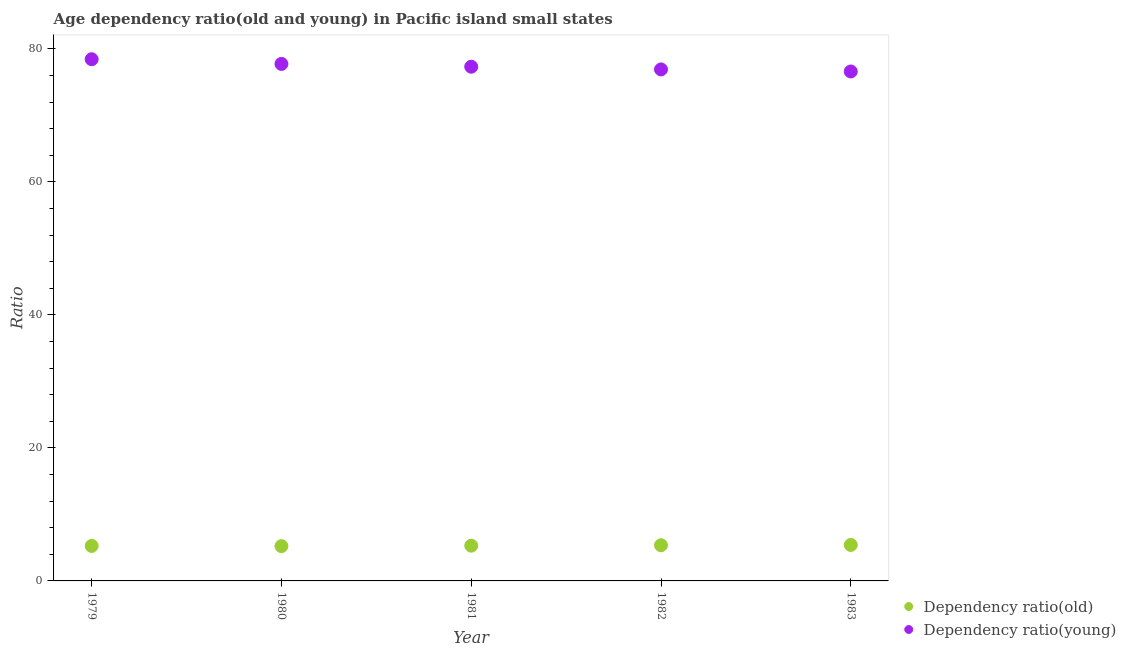How many different coloured dotlines are there?
Give a very brief answer. 2. Is the number of dotlines equal to the number of legend labels?
Keep it short and to the point. Yes. What is the age dependency ratio(old) in 1979?
Provide a succinct answer. 5.26. Across all years, what is the maximum age dependency ratio(young)?
Make the answer very short. 78.45. Across all years, what is the minimum age dependency ratio(old)?
Your answer should be very brief. 5.23. In which year was the age dependency ratio(young) maximum?
Give a very brief answer. 1979. In which year was the age dependency ratio(young) minimum?
Offer a very short reply. 1983. What is the total age dependency ratio(young) in the graph?
Offer a terse response. 387.02. What is the difference between the age dependency ratio(young) in 1980 and that in 1981?
Your response must be concise. 0.42. What is the difference between the age dependency ratio(young) in 1981 and the age dependency ratio(old) in 1979?
Make the answer very short. 72.06. What is the average age dependency ratio(old) per year?
Give a very brief answer. 5.31. In the year 1981, what is the difference between the age dependency ratio(old) and age dependency ratio(young)?
Make the answer very short. -72.02. In how many years, is the age dependency ratio(old) greater than 52?
Give a very brief answer. 0. What is the ratio of the age dependency ratio(old) in 1982 to that in 1983?
Offer a very short reply. 0.99. What is the difference between the highest and the second highest age dependency ratio(young)?
Your answer should be very brief. 0.71. What is the difference between the highest and the lowest age dependency ratio(young)?
Offer a very short reply. 1.84. Does the age dependency ratio(young) monotonically increase over the years?
Offer a very short reply. No. Is the age dependency ratio(young) strictly greater than the age dependency ratio(old) over the years?
Offer a terse response. Yes. Is the age dependency ratio(young) strictly less than the age dependency ratio(old) over the years?
Ensure brevity in your answer.  No. How many dotlines are there?
Provide a succinct answer. 2. Are the values on the major ticks of Y-axis written in scientific E-notation?
Offer a very short reply. No. Does the graph contain grids?
Your answer should be compact. No. Where does the legend appear in the graph?
Your answer should be very brief. Bottom right. How many legend labels are there?
Your response must be concise. 2. What is the title of the graph?
Ensure brevity in your answer.  Age dependency ratio(old and young) in Pacific island small states. Does "Grants" appear as one of the legend labels in the graph?
Keep it short and to the point. No. What is the label or title of the X-axis?
Provide a short and direct response. Year. What is the label or title of the Y-axis?
Offer a terse response. Ratio. What is the Ratio in Dependency ratio(old) in 1979?
Your answer should be very brief. 5.26. What is the Ratio in Dependency ratio(young) in 1979?
Your response must be concise. 78.45. What is the Ratio in Dependency ratio(old) in 1980?
Give a very brief answer. 5.23. What is the Ratio in Dependency ratio(young) in 1980?
Provide a short and direct response. 77.74. What is the Ratio in Dependency ratio(old) in 1981?
Offer a terse response. 5.3. What is the Ratio of Dependency ratio(young) in 1981?
Give a very brief answer. 77.32. What is the Ratio of Dependency ratio(old) in 1982?
Offer a terse response. 5.36. What is the Ratio in Dependency ratio(young) in 1982?
Offer a very short reply. 76.91. What is the Ratio of Dependency ratio(old) in 1983?
Give a very brief answer. 5.41. What is the Ratio in Dependency ratio(young) in 1983?
Your answer should be very brief. 76.6. Across all years, what is the maximum Ratio of Dependency ratio(old)?
Give a very brief answer. 5.41. Across all years, what is the maximum Ratio in Dependency ratio(young)?
Your response must be concise. 78.45. Across all years, what is the minimum Ratio in Dependency ratio(old)?
Give a very brief answer. 5.23. Across all years, what is the minimum Ratio of Dependency ratio(young)?
Ensure brevity in your answer.  76.6. What is the total Ratio in Dependency ratio(old) in the graph?
Provide a short and direct response. 26.57. What is the total Ratio of Dependency ratio(young) in the graph?
Offer a very short reply. 387.02. What is the difference between the Ratio in Dependency ratio(old) in 1979 and that in 1980?
Your answer should be very brief. 0.03. What is the difference between the Ratio in Dependency ratio(young) in 1979 and that in 1980?
Offer a very short reply. 0.71. What is the difference between the Ratio of Dependency ratio(old) in 1979 and that in 1981?
Your answer should be very brief. -0.04. What is the difference between the Ratio of Dependency ratio(young) in 1979 and that in 1981?
Your answer should be compact. 1.13. What is the difference between the Ratio of Dependency ratio(old) in 1979 and that in 1982?
Keep it short and to the point. -0.1. What is the difference between the Ratio of Dependency ratio(young) in 1979 and that in 1982?
Offer a terse response. 1.53. What is the difference between the Ratio of Dependency ratio(old) in 1979 and that in 1983?
Your response must be concise. -0.15. What is the difference between the Ratio in Dependency ratio(young) in 1979 and that in 1983?
Provide a succinct answer. 1.84. What is the difference between the Ratio in Dependency ratio(old) in 1980 and that in 1981?
Your answer should be compact. -0.07. What is the difference between the Ratio of Dependency ratio(young) in 1980 and that in 1981?
Ensure brevity in your answer.  0.42. What is the difference between the Ratio of Dependency ratio(old) in 1980 and that in 1982?
Your answer should be compact. -0.13. What is the difference between the Ratio in Dependency ratio(young) in 1980 and that in 1982?
Your response must be concise. 0.83. What is the difference between the Ratio of Dependency ratio(old) in 1980 and that in 1983?
Give a very brief answer. -0.18. What is the difference between the Ratio in Dependency ratio(young) in 1980 and that in 1983?
Provide a short and direct response. 1.14. What is the difference between the Ratio of Dependency ratio(old) in 1981 and that in 1982?
Keep it short and to the point. -0.06. What is the difference between the Ratio in Dependency ratio(young) in 1981 and that in 1982?
Provide a succinct answer. 0.41. What is the difference between the Ratio of Dependency ratio(old) in 1981 and that in 1983?
Your answer should be compact. -0.11. What is the difference between the Ratio in Dependency ratio(young) in 1981 and that in 1983?
Make the answer very short. 0.72. What is the difference between the Ratio in Dependency ratio(old) in 1982 and that in 1983?
Your answer should be very brief. -0.05. What is the difference between the Ratio of Dependency ratio(young) in 1982 and that in 1983?
Your answer should be very brief. 0.31. What is the difference between the Ratio in Dependency ratio(old) in 1979 and the Ratio in Dependency ratio(young) in 1980?
Your response must be concise. -72.48. What is the difference between the Ratio of Dependency ratio(old) in 1979 and the Ratio of Dependency ratio(young) in 1981?
Your answer should be very brief. -72.06. What is the difference between the Ratio of Dependency ratio(old) in 1979 and the Ratio of Dependency ratio(young) in 1982?
Provide a short and direct response. -71.65. What is the difference between the Ratio in Dependency ratio(old) in 1979 and the Ratio in Dependency ratio(young) in 1983?
Provide a short and direct response. -71.34. What is the difference between the Ratio of Dependency ratio(old) in 1980 and the Ratio of Dependency ratio(young) in 1981?
Your answer should be compact. -72.09. What is the difference between the Ratio in Dependency ratio(old) in 1980 and the Ratio in Dependency ratio(young) in 1982?
Provide a short and direct response. -71.68. What is the difference between the Ratio of Dependency ratio(old) in 1980 and the Ratio of Dependency ratio(young) in 1983?
Your answer should be compact. -71.37. What is the difference between the Ratio in Dependency ratio(old) in 1981 and the Ratio in Dependency ratio(young) in 1982?
Your answer should be very brief. -71.61. What is the difference between the Ratio in Dependency ratio(old) in 1981 and the Ratio in Dependency ratio(young) in 1983?
Provide a succinct answer. -71.3. What is the difference between the Ratio of Dependency ratio(old) in 1982 and the Ratio of Dependency ratio(young) in 1983?
Give a very brief answer. -71.24. What is the average Ratio of Dependency ratio(old) per year?
Provide a short and direct response. 5.31. What is the average Ratio of Dependency ratio(young) per year?
Your answer should be compact. 77.4. In the year 1979, what is the difference between the Ratio of Dependency ratio(old) and Ratio of Dependency ratio(young)?
Your answer should be very brief. -73.19. In the year 1980, what is the difference between the Ratio of Dependency ratio(old) and Ratio of Dependency ratio(young)?
Offer a terse response. -72.51. In the year 1981, what is the difference between the Ratio of Dependency ratio(old) and Ratio of Dependency ratio(young)?
Give a very brief answer. -72.02. In the year 1982, what is the difference between the Ratio in Dependency ratio(old) and Ratio in Dependency ratio(young)?
Give a very brief answer. -71.55. In the year 1983, what is the difference between the Ratio of Dependency ratio(old) and Ratio of Dependency ratio(young)?
Give a very brief answer. -71.19. What is the ratio of the Ratio of Dependency ratio(old) in 1979 to that in 1980?
Your response must be concise. 1.01. What is the ratio of the Ratio in Dependency ratio(young) in 1979 to that in 1980?
Provide a short and direct response. 1.01. What is the ratio of the Ratio of Dependency ratio(old) in 1979 to that in 1981?
Your answer should be very brief. 0.99. What is the ratio of the Ratio in Dependency ratio(young) in 1979 to that in 1981?
Your answer should be very brief. 1.01. What is the ratio of the Ratio of Dependency ratio(old) in 1979 to that in 1982?
Your answer should be compact. 0.98. What is the ratio of the Ratio in Dependency ratio(young) in 1979 to that in 1982?
Keep it short and to the point. 1.02. What is the ratio of the Ratio of Dependency ratio(old) in 1979 to that in 1983?
Your answer should be compact. 0.97. What is the ratio of the Ratio in Dependency ratio(young) in 1979 to that in 1983?
Keep it short and to the point. 1.02. What is the ratio of the Ratio of Dependency ratio(old) in 1980 to that in 1981?
Ensure brevity in your answer.  0.99. What is the ratio of the Ratio of Dependency ratio(young) in 1980 to that in 1981?
Give a very brief answer. 1.01. What is the ratio of the Ratio of Dependency ratio(old) in 1980 to that in 1982?
Your answer should be compact. 0.98. What is the ratio of the Ratio of Dependency ratio(young) in 1980 to that in 1982?
Provide a short and direct response. 1.01. What is the ratio of the Ratio of Dependency ratio(old) in 1980 to that in 1983?
Provide a succinct answer. 0.97. What is the ratio of the Ratio of Dependency ratio(young) in 1980 to that in 1983?
Your answer should be compact. 1.01. What is the ratio of the Ratio in Dependency ratio(young) in 1981 to that in 1982?
Offer a very short reply. 1.01. What is the ratio of the Ratio in Dependency ratio(old) in 1981 to that in 1983?
Your answer should be very brief. 0.98. What is the ratio of the Ratio of Dependency ratio(young) in 1981 to that in 1983?
Your answer should be very brief. 1.01. What is the ratio of the Ratio of Dependency ratio(young) in 1982 to that in 1983?
Ensure brevity in your answer.  1. What is the difference between the highest and the second highest Ratio in Dependency ratio(old)?
Your answer should be compact. 0.05. What is the difference between the highest and the second highest Ratio of Dependency ratio(young)?
Your response must be concise. 0.71. What is the difference between the highest and the lowest Ratio in Dependency ratio(old)?
Offer a terse response. 0.18. What is the difference between the highest and the lowest Ratio of Dependency ratio(young)?
Make the answer very short. 1.84. 